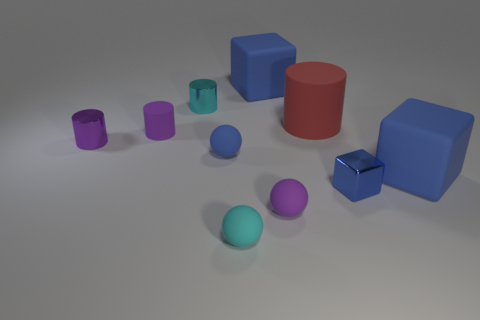Is there anything else that has the same color as the tiny cube?
Make the answer very short. Yes. There is a cube behind the tiny rubber cylinder; how big is it?
Your response must be concise. Large. How big is the blue rubber block that is behind the large blue cube that is on the right side of the blue block behind the tiny blue rubber sphere?
Make the answer very short. Large. There is a ball to the right of the large blue object to the left of the small blue cube; what color is it?
Offer a very short reply. Purple. What is the material of the small cyan thing that is the same shape as the small blue matte thing?
Provide a short and direct response. Rubber. Is there anything else that has the same material as the tiny cyan cylinder?
Ensure brevity in your answer.  Yes. There is a cyan rubber thing; are there any balls to the left of it?
Provide a short and direct response. Yes. What number of small cyan blocks are there?
Offer a very short reply. 0. There is a purple metallic object behind the small purple ball; how many purple metal cylinders are on the left side of it?
Your response must be concise. 0. Do the small block and the matte sphere to the left of the tiny cyan matte thing have the same color?
Give a very brief answer. Yes. 